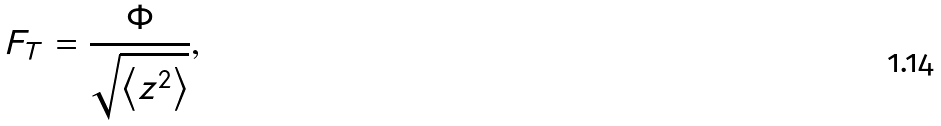Convert formula to latex. <formula><loc_0><loc_0><loc_500><loc_500>F _ { T } = \frac { \Phi } { \sqrt { \left \langle z ^ { 2 } \right \rangle } } ,</formula> 